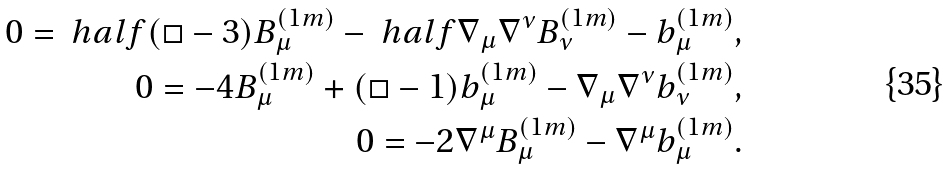Convert formula to latex. <formula><loc_0><loc_0><loc_500><loc_500>0 = \ h a l f ( \Box - 3 ) B _ { \mu } ^ { ( 1 m ) } - \ h a l f \nabla _ { \mu } \nabla ^ { \nu } B ^ { ( 1 m ) } _ { \nu } - b ^ { ( 1 m ) } _ { \mu } , \\ 0 = - 4 B ^ { ( 1 m ) } _ { \mu } + ( \Box - 1 ) b ^ { ( 1 m ) } _ { \mu } - \nabla _ { \mu } \nabla ^ { \nu } b ^ { ( 1 m ) } _ { \nu } , \\ 0 = - 2 \nabla ^ { \mu } B ^ { ( 1 m ) } _ { \mu } - \nabla ^ { \mu } b ^ { ( 1 m ) } _ { \mu } .</formula> 